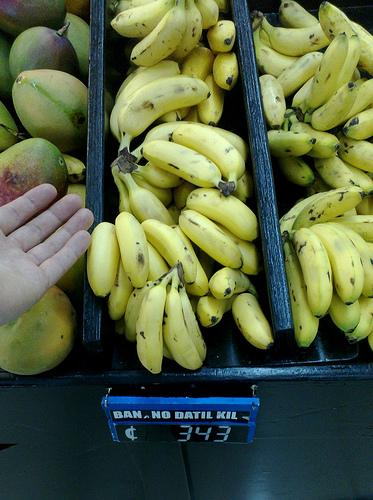What is the main color of the price sign and what is the color of the text on it? The main color of the price sign is blue, and the text on it is white. Please provide a brief sentiment analysis for this image. The image has a positive and vibrant sentiment due to the variety of colorful fruits and the potential action of someone reaching for them, indicating freshness and a healthy choice. Determine the main subject and action happening in the image by considering the position of the human hand and what it might be reaching for. The main subject and action in the image is a person's hand reaching for a fruit, possibly a mango, among a variety of displayed fruits at a small fruit stand. What is the most common type of fruit in the image? Bananas seem to be the most common fruit in the image. What is the position of the person's hand, and how many fingers are visible? The position of the person's hand is palm up, and four fingers are visible. Explain the purpose of the wooden separator in the context of this image. The wooden separator’s purpose is to divide the fruit bins, keeping different types of fruits separate and organized. Identify what type of task image segmentation would be useful for in this image. Image segmentation would be useful for identifying and analyzing various fruits and their locations in the image. Is there anything in the image that suggests unripe or spoiled fruit and what is it? There is a banana with black spots, which might indicate that it is starting to spoil or overly ripe. What might be the purpose of the blue price sign in the context of this image? The purpose of the blue price sign is to display the price of the fruits, particularly bananas, to prospective customers. Find the discrepancy, if any, between the features of the red and green mangoes near each other in the image. There doesn't seem to be any significant discrepancy between the red and green mangoes; they are just positioned next to each other with slightly different colors. Does the wooden divider have a blue and white stripe? There is a painted wooden divider and a dark colored wooden divider, but there is no mention of a wooden divider with a blue and white stripe in the image. Is the sign displaying the price of mangoes? There is a sign displaying the price of bananas, but there is no mention of a sign displaying the price for mangoes in the image. Can you find a hand holding a green mango? There is an open palmed hand and a hand showing four fingers, but there is no mention of a hand holding a green mango in the image. Do the bananas have green spots on them? There is a mention of a bright yellow bunch of bananas and a banana with black spots, but there is no mention of bananas with green spots in the image. Is there a red mango near the green mango? The image has a green mango near bananas and a red and green mango next to a mango, but there is no mention of a completely red mango. Can you locate a brown hand reaching for the fruit? There is a mention of a caucasian hand over mangoes, but there is no mention of a brown hand in the image. 